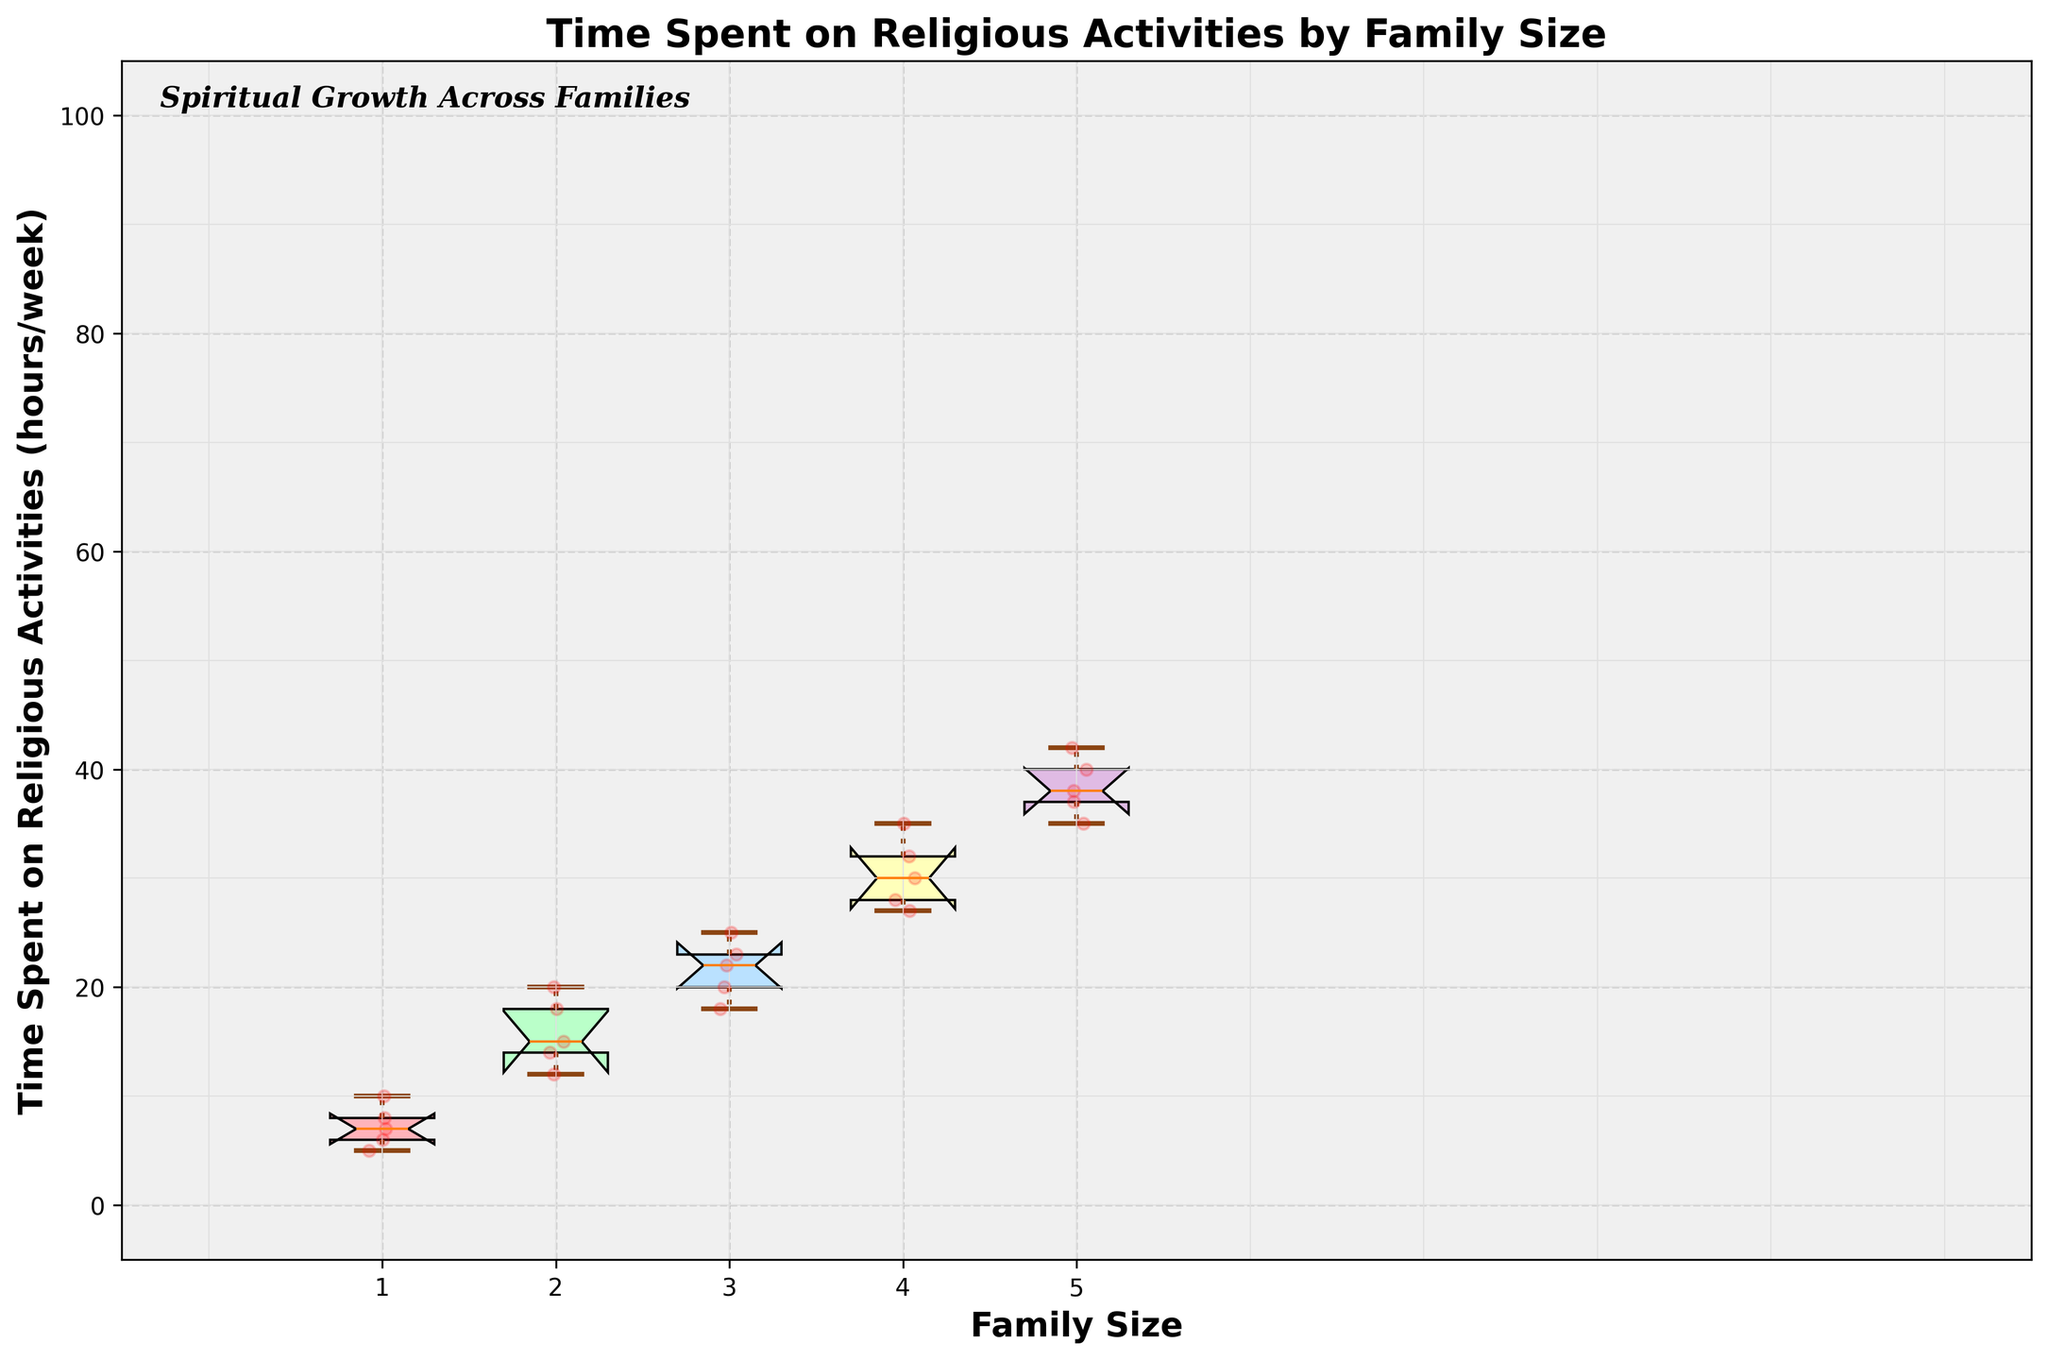What is the title of the figure? The title of the figure is prominently displayed at the top and reads "Time Spent on Religious Activities by Family Size."
Answer: Time Spent on Religious Activities by Family Size Which family size group has the highest median time spent on religious activities? The highest median is indicated by the line within the box that is highest on the y-axis. For this figure, it is the family size group of 5.
Answer: Family size 5 What is the color of the box for the family size group of 4? The box for the family size group of 4 is the fourth one from the left and is colored in yellow.
Answer: Yellow How many family size groups are represented in the figure? The x-axis labels show unique numbers for family sizes, and there are five distinct tick marks.
Answer: 5 Which family size group shows the greatest variability in time spent on religious activities? The group with the widest box (largest interquartile range) indicates the greatest variability. This appears to be the family size 5.
Answer: Family size 5 What is the smallest value of time spent on religious activities for family size group 1? The minimum value is indicated by the bottom whisker of the box plot for family size 1, which extends down to 5.
Answer: 5 How does the median time spent on religious activities for family size 3 compare to family size 2? The median for family size 3 is higher than the median for family size 2, as indicated by the higher position of the median line within the box.
Answer: Higher What is the range of time spent on religious activities for family size group 4? The range is the difference between the maximum and minimum values, indicated by the whiskers for the family size 4 box plot. The maximum is 35 and the minimum is 27, so the range is 35 - 27 = 8.
Answer: 8 How are the data points visually represented on the figure? The figure shows individual data points as red dots that are jittered around their respective family sizes.
Answer: Red dots Descrition mentions some kind of pattern added to the background of the figure; name and detail it. The background of the figure includes a cross pattern created by horizontal and vertical lines spaced at intervals, contributing to the structured appearance. These lines are light grey and provide additional visual context for the data.
Answer: Cross pattern 